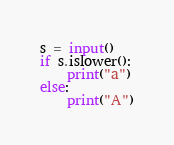Convert code to text. <code><loc_0><loc_0><loc_500><loc_500><_Python_>s = input()
if s.islower():
    print("a")
else:
    print("A")</code> 